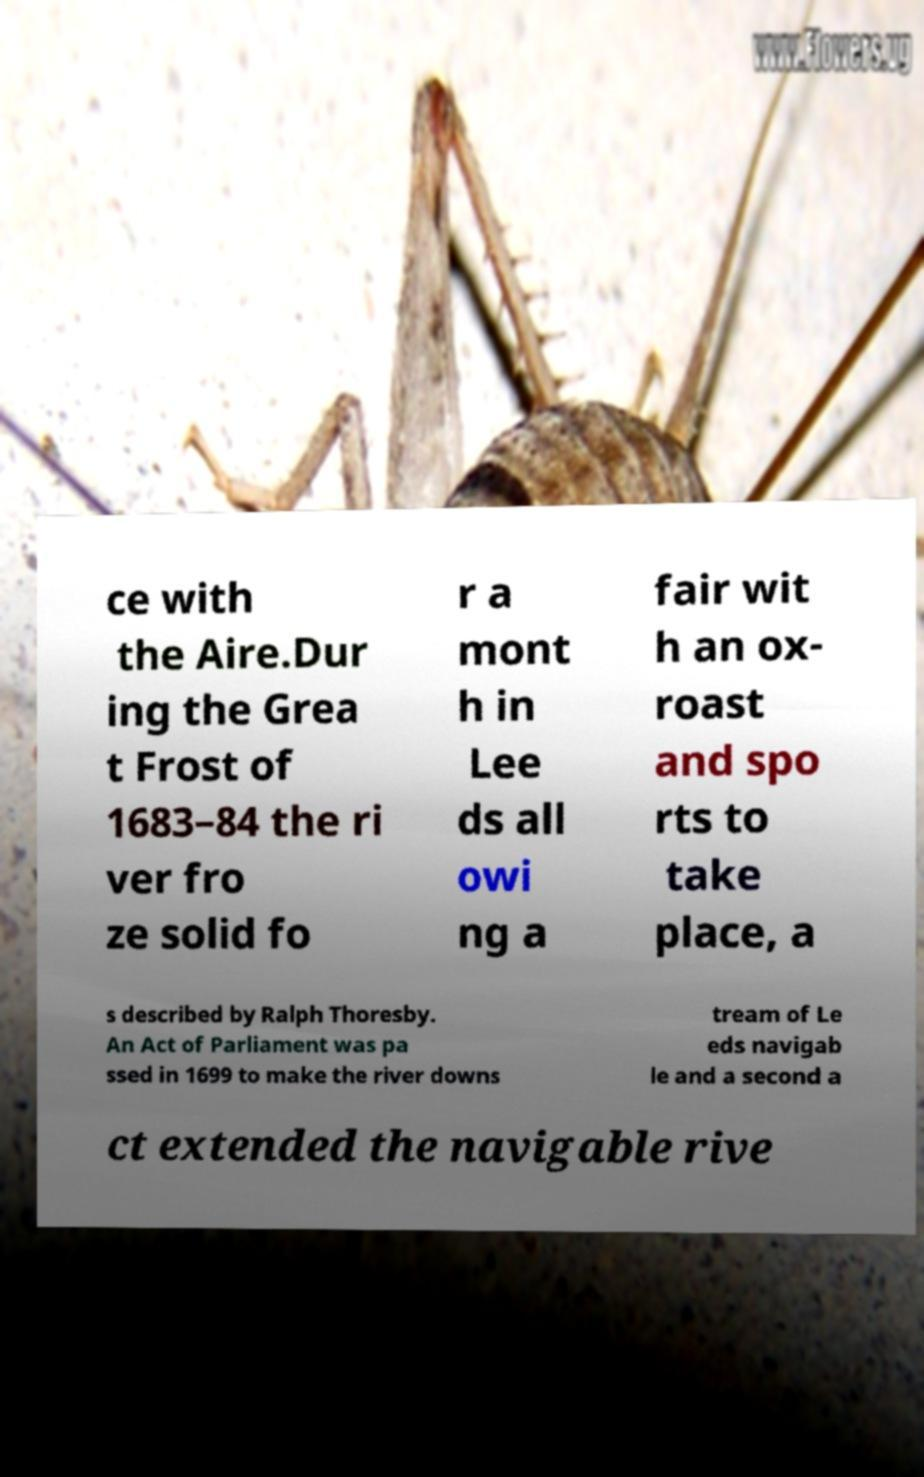There's text embedded in this image that I need extracted. Can you transcribe it verbatim? ce with the Aire.Dur ing the Grea t Frost of 1683–84 the ri ver fro ze solid fo r a mont h in Lee ds all owi ng a fair wit h an ox- roast and spo rts to take place, a s described by Ralph Thoresby. An Act of Parliament was pa ssed in 1699 to make the river downs tream of Le eds navigab le and a second a ct extended the navigable rive 